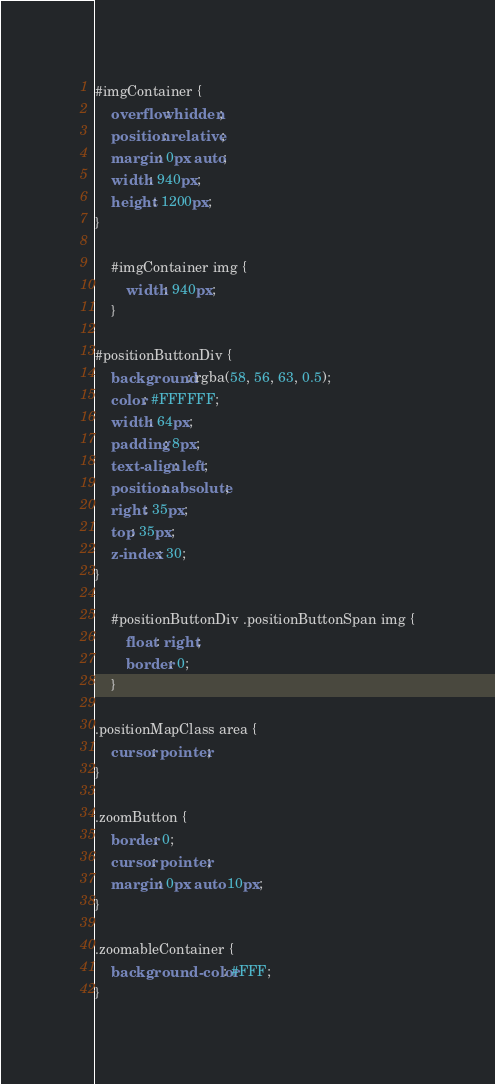<code> <loc_0><loc_0><loc_500><loc_500><_CSS_>#imgContainer {
    overflow: hidden;
    position: relative;
    margin: 0px auto;
    width: 940px;
    height: 1200px;
}

    #imgContainer img {
        width: 940px;
    }

#positionButtonDiv {
    background: rgba(58, 56, 63, 0.5);
    color: #FFFFFF;
    width: 64px;
    padding: 8px;
    text-align: left;
    position: absolute;
    right: 35px;
    top: 35px;
    z-index: 30;
}

    #positionButtonDiv .positionButtonSpan img {
        float: right;
        border: 0;
    }

.positionMapClass area {
    cursor: pointer;
}

.zoomButton {
    border: 0;
    cursor: pointer;
    margin: 0px auto 10px;
}

.zoomableContainer {
    background-color: #FFF;
}
</code> 